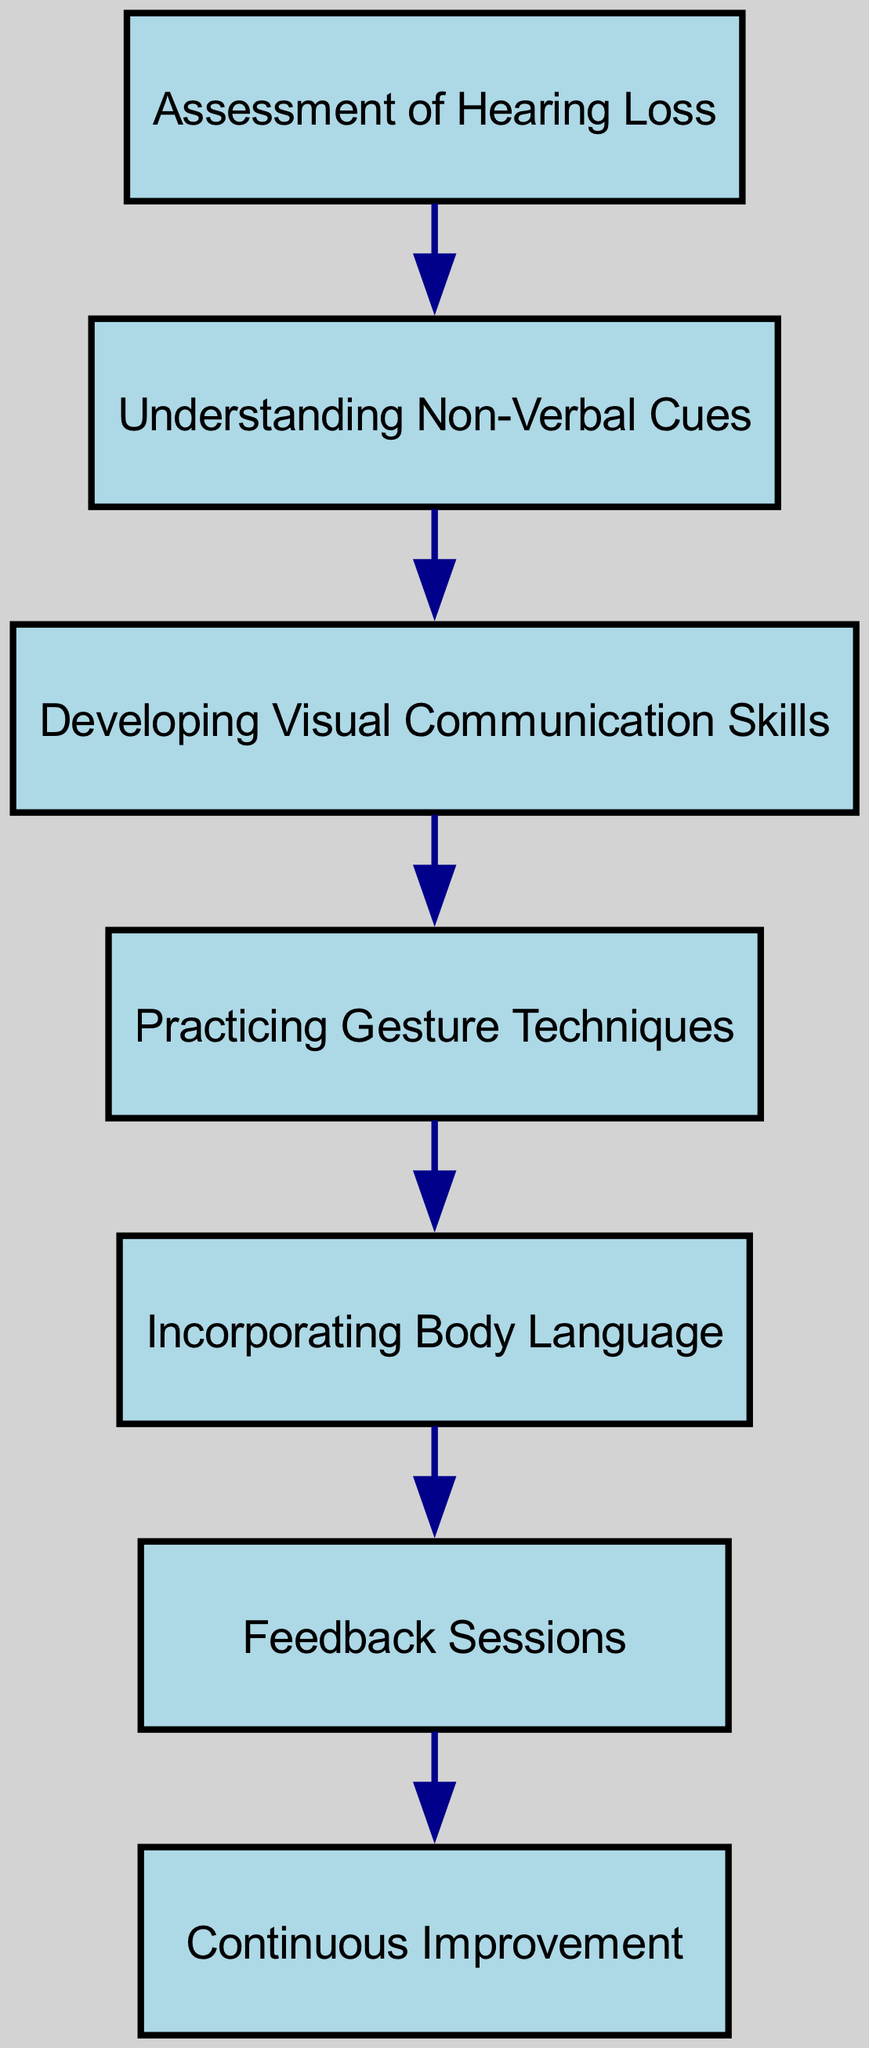What is the first step in the training sequence? The first node in the directed graph is "Assessment of Hearing Loss", indicating that this is the initial step in the process before any other activities occur.
Answer: Assessment of Hearing Loss How many nodes are present in the diagram? By counting the nodes listed in the data, we see that there are 7 unique steps, corresponding to each described item in the training sequence.
Answer: 7 What is the last step in the training sequence? The final node reached in the sequence is "Continuous Improvement", which indicates the last stage after the feedback sessions.
Answer: Continuous Improvement What are the two steps that come before "Incorporating Body Language"? In the directed graph, "Practicing Gesture Techniques" leads to "Incorporating Body Language" with "Developing Visual Communication Skills" also preceding it, as seen in the connections of the nodes.
Answer: Practicing Gesture Techniques; Developing Visual Communication Skills Which step follows "Feedback Sessions"? According to the directed connections in the graph, "Continuous Improvement" is the step that directly follows "Feedback Sessions", showing the progression from feedback to improvement.
Answer: Continuous Improvement How many edges are there in the directed graph? The edges define the connections or steps between nodes, and by counting the edges provided, we see that there are 6 connections that illustrate the flow of training.
Answer: 6 What are the immediate preceding steps to "Practicing Gesture Techniques"? To identify the preceding steps, we look for the node that points to "Practicing Gesture Techniques", which is "Developing Visual Communication Skills", denoting the sequence of learning before practicing.
Answer: Developing Visual Communication Skills Which concept is introduced right after "Understanding Non-Verbal Cues"? Based on the directed flow of the graph, the step that comes immediately after "Understanding Non-Verbal Cues" is "Developing Visual Communication Skills", indicating a progression in the training approach.
Answer: Developing Visual Communication Skills What type of communication skills are developed after assessing hearing loss? "Understanding Non-Verbal Cues" is the next concept introduced immediately after the assessment step, which focuses on non-verbal communication skills necessary for conductors.
Answer: Understanding Non-Verbal Cues 